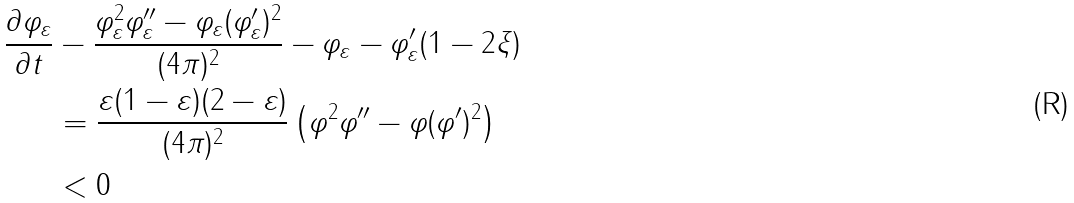<formula> <loc_0><loc_0><loc_500><loc_500>\frac { \partial \varphi _ { \varepsilon } } { \partial t } & - \frac { \varphi _ { \varepsilon } ^ { 2 } \varphi _ { \varepsilon } ^ { \prime \prime } - \varphi _ { \varepsilon } ( \varphi _ { \varepsilon } ^ { \prime } ) ^ { 2 } } { ( 4 \pi ) ^ { 2 } } - \varphi _ { \varepsilon } - \varphi _ { \varepsilon } ^ { \prime } ( 1 - 2 \xi ) \\ & = \frac { \varepsilon ( 1 - \varepsilon ) ( 2 - \varepsilon ) } { ( 4 \pi ) ^ { 2 } } \left ( \varphi ^ { 2 } \varphi ^ { \prime \prime } - \varphi ( \varphi ^ { \prime } ) ^ { 2 } \right ) \\ & < 0</formula> 